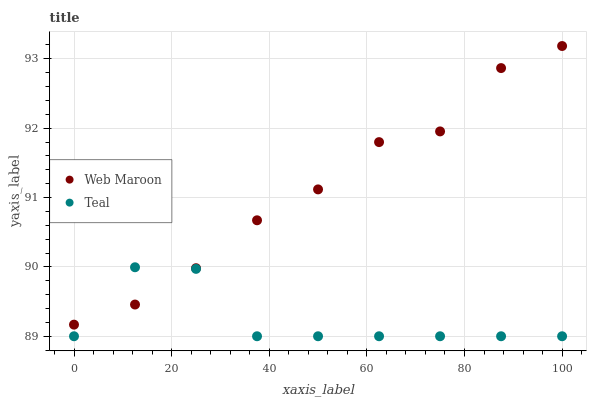Does Teal have the minimum area under the curve?
Answer yes or no. Yes. Does Web Maroon have the maximum area under the curve?
Answer yes or no. Yes. Does Teal have the maximum area under the curve?
Answer yes or no. No. Is Web Maroon the smoothest?
Answer yes or no. Yes. Is Teal the roughest?
Answer yes or no. Yes. Is Teal the smoothest?
Answer yes or no. No. Does Teal have the lowest value?
Answer yes or no. Yes. Does Web Maroon have the highest value?
Answer yes or no. Yes. Does Teal have the highest value?
Answer yes or no. No. Does Web Maroon intersect Teal?
Answer yes or no. Yes. Is Web Maroon less than Teal?
Answer yes or no. No. Is Web Maroon greater than Teal?
Answer yes or no. No. 